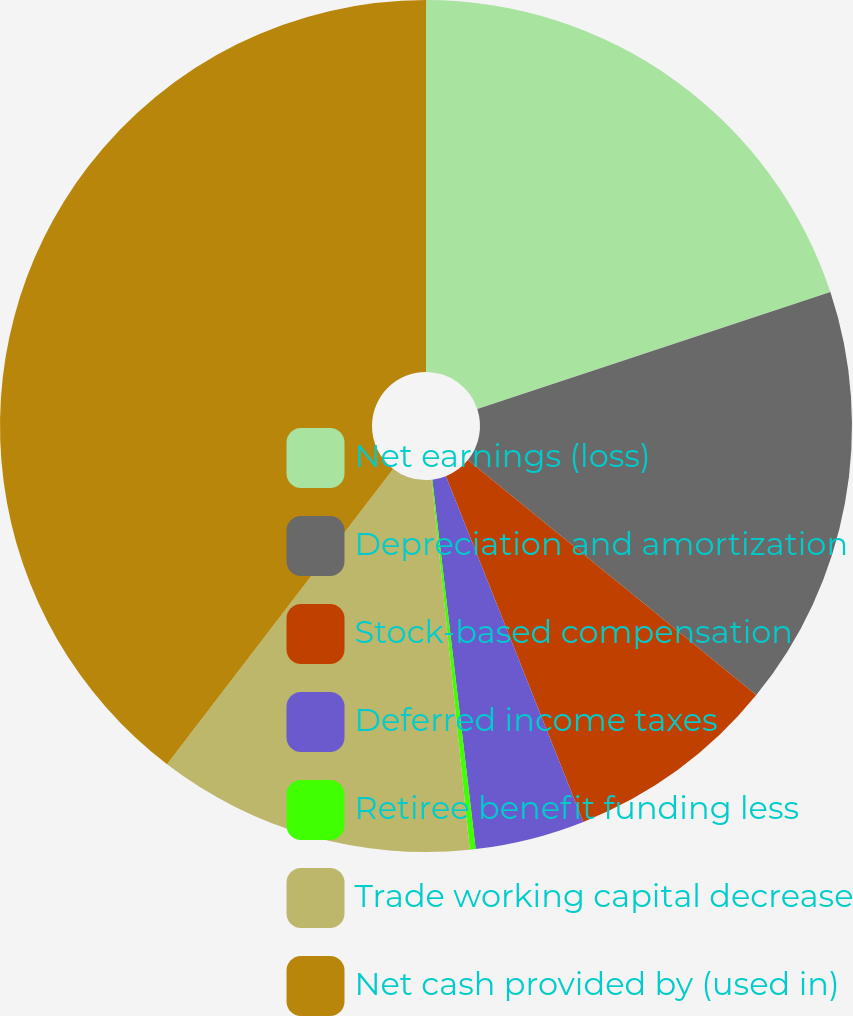Convert chart to OTSL. <chart><loc_0><loc_0><loc_500><loc_500><pie_chart><fcel>Net earnings (loss)<fcel>Depreciation and amortization<fcel>Stock-based compensation<fcel>Deferred income taxes<fcel>Retiree benefit funding less<fcel>Trade working capital decrease<fcel>Net cash provided by (used in)<nl><fcel>19.91%<fcel>15.97%<fcel>8.1%<fcel>4.16%<fcel>0.22%<fcel>12.04%<fcel>39.6%<nl></chart> 